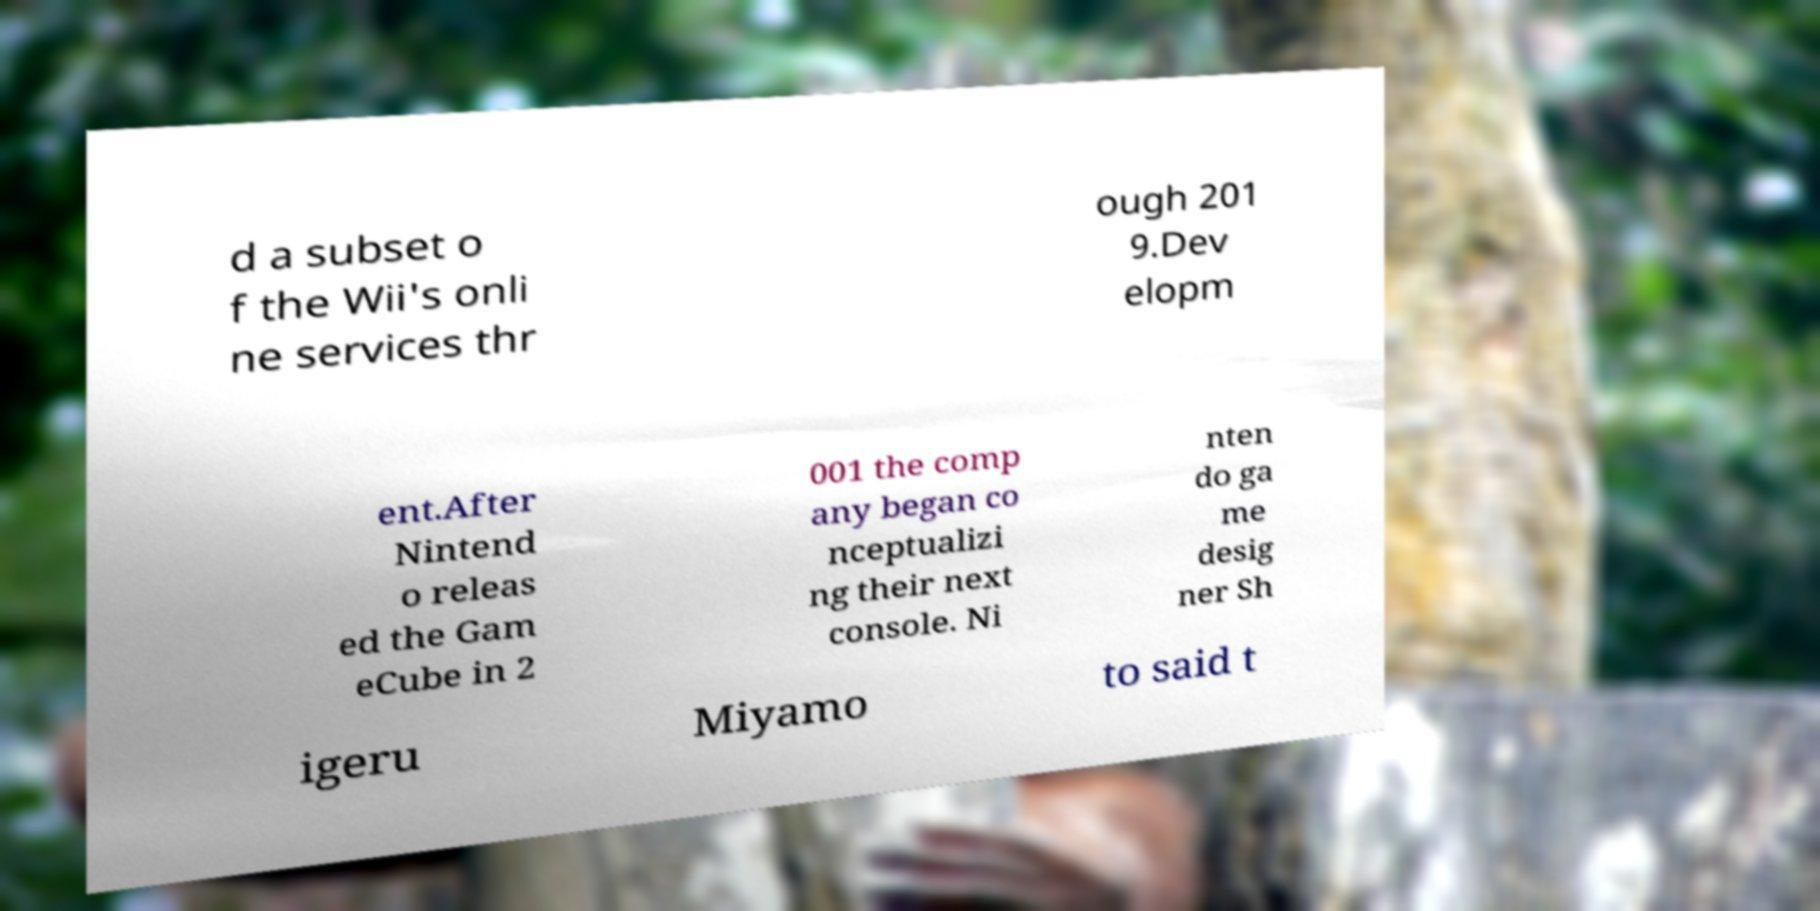Please identify and transcribe the text found in this image. d a subset o f the Wii's onli ne services thr ough 201 9.Dev elopm ent.After Nintend o releas ed the Gam eCube in 2 001 the comp any began co nceptualizi ng their next console. Ni nten do ga me desig ner Sh igeru Miyamo to said t 